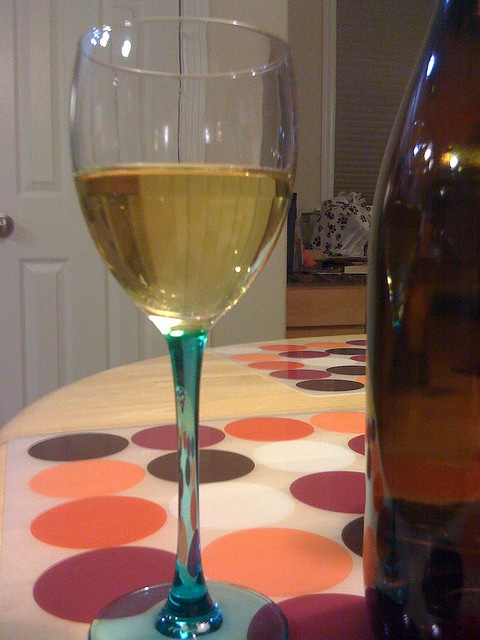Describe the objects in this image and their specific colors. I can see dining table in gray, tan, and salmon tones, wine glass in gray and olive tones, and bottle in gray, black, maroon, and olive tones in this image. 